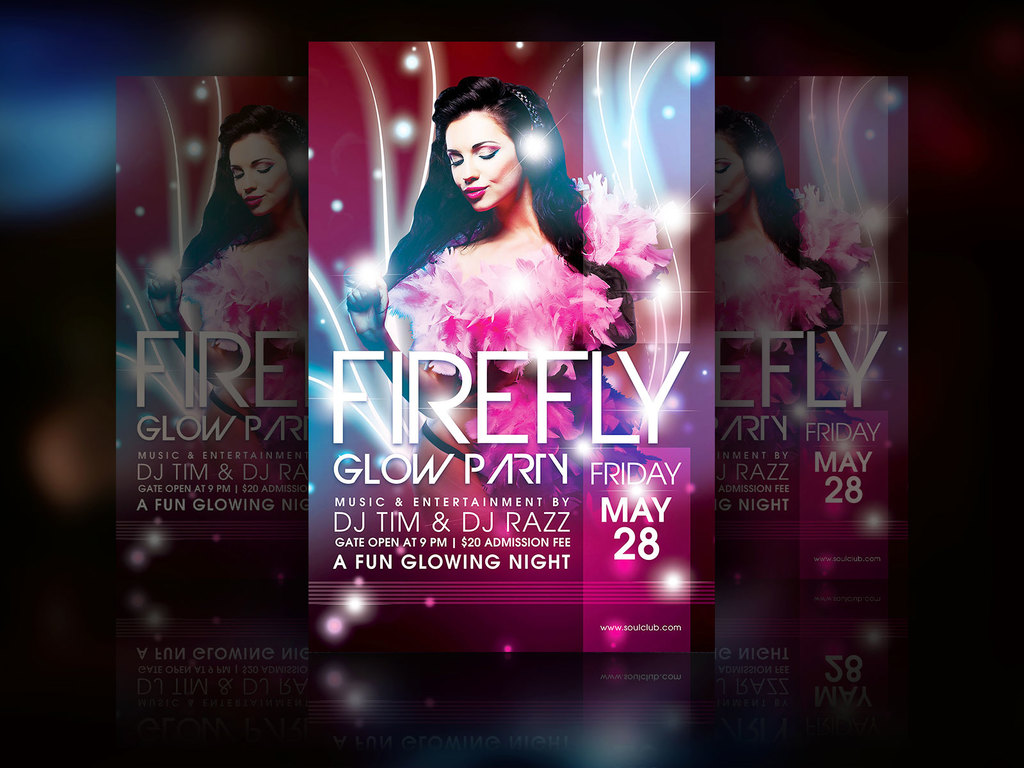Provide a one-sentence caption for the provided image. The image is a vibrant, color-saturated advertisement for a 'Firefly Glow Party' featuring DJ Tim & DJ Razz, scheduled for Friday, May 28th, with a fun, glowing night theme. 